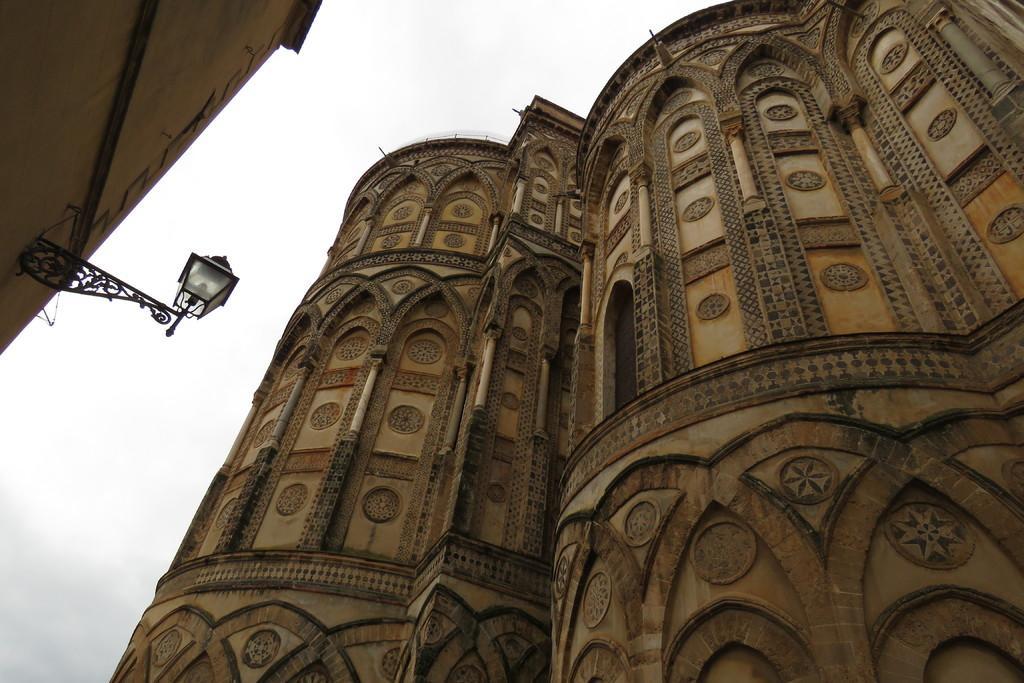Describe this image in one or two sentences. In front of the picture, we see a building or a castle. In the left top of the picture, we see a street light and a building. In the background, we see the sky. 